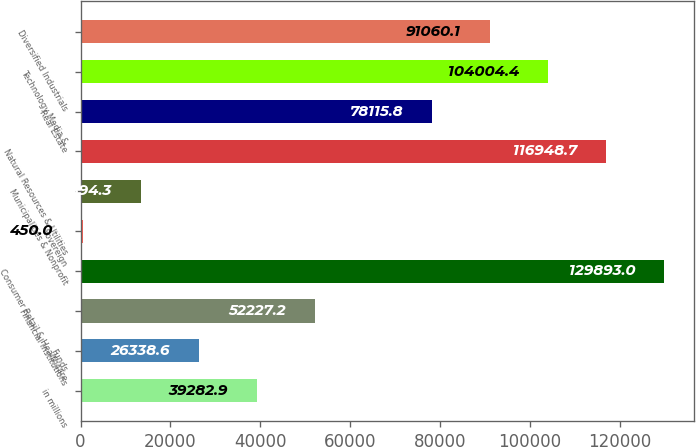Convert chart. <chart><loc_0><loc_0><loc_500><loc_500><bar_chart><fcel>in millions<fcel>Funds<fcel>Financial Institutions<fcel>Consumer Retail & Healthcare<fcel>Sovereign<fcel>Municipalities & Nonprofit<fcel>Natural Resources & Utilities<fcel>Real Estate<fcel>Technology Media &<fcel>Diversified Industrials<nl><fcel>39282.9<fcel>26338.6<fcel>52227.2<fcel>129893<fcel>450<fcel>13394.3<fcel>116949<fcel>78115.8<fcel>104004<fcel>91060.1<nl></chart> 